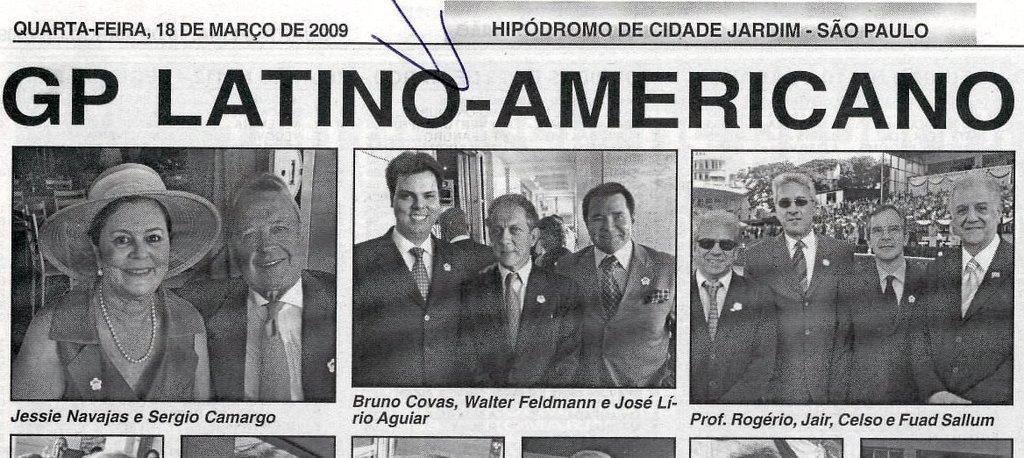How would you summarize this image in a sentence or two? In this image I can see photos of people. I can see most of them are wearing formal dress and few of them are wearing shades. I can also see smile on their faces and I can also see something is written at few places. I can see this image is black and white in colour. 